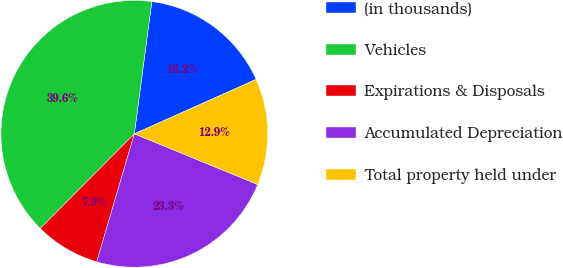Convert chart. <chart><loc_0><loc_0><loc_500><loc_500><pie_chart><fcel>(in thousands)<fcel>Vehicles<fcel>Expirations & Disposals<fcel>Accumulated Depreciation<fcel>Total property held under<nl><fcel>16.22%<fcel>39.63%<fcel>7.91%<fcel>23.34%<fcel>12.9%<nl></chart> 